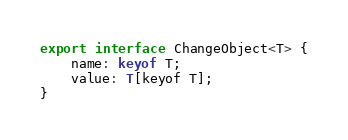<code> <loc_0><loc_0><loc_500><loc_500><_TypeScript_>export interface ChangeObject<T> {
    name: keyof T;
    value: T[keyof T];
}
</code> 